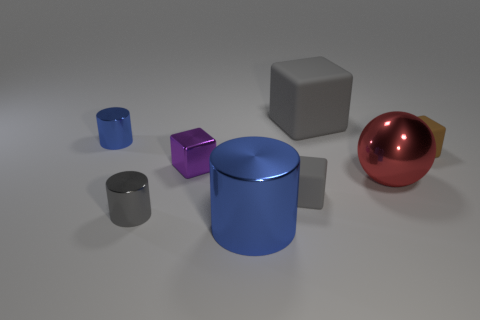Are there fewer blue metallic cylinders than large yellow balls?
Your answer should be very brief. No. What number of things are brown rubber cylinders or small matte objects?
Provide a short and direct response. 2. Is the purple metal object the same shape as the tiny blue metal object?
Your response must be concise. No. Is there any other thing that has the same material as the tiny brown block?
Keep it short and to the point. Yes. Is the size of the cube that is right of the large red shiny sphere the same as the gray rubber block that is behind the tiny gray cube?
Your answer should be compact. No. There is a object that is both behind the large shiny cylinder and in front of the small gray rubber cube; what is it made of?
Offer a very short reply. Metal. Are there any other things of the same color as the big cylinder?
Offer a very short reply. Yes. Are there fewer purple things in front of the small purple metallic object than small cubes?
Offer a very short reply. Yes. Is the number of cubes greater than the number of gray matte objects?
Provide a succinct answer. Yes. Are there any blue objects in front of the tiny blue cylinder to the left of the cylinder that is on the right side of the tiny purple metal block?
Give a very brief answer. Yes. 